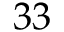<formula> <loc_0><loc_0><loc_500><loc_500>3 3</formula> 